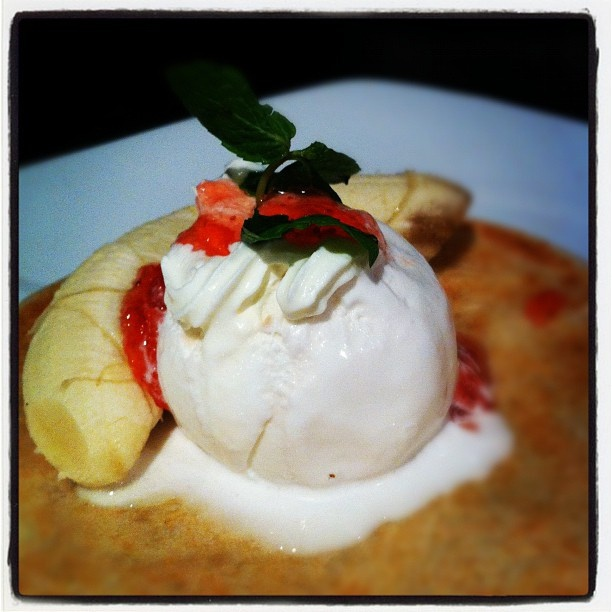Describe the objects in this image and their specific colors. I can see a banana in white, tan, khaki, and maroon tones in this image. 